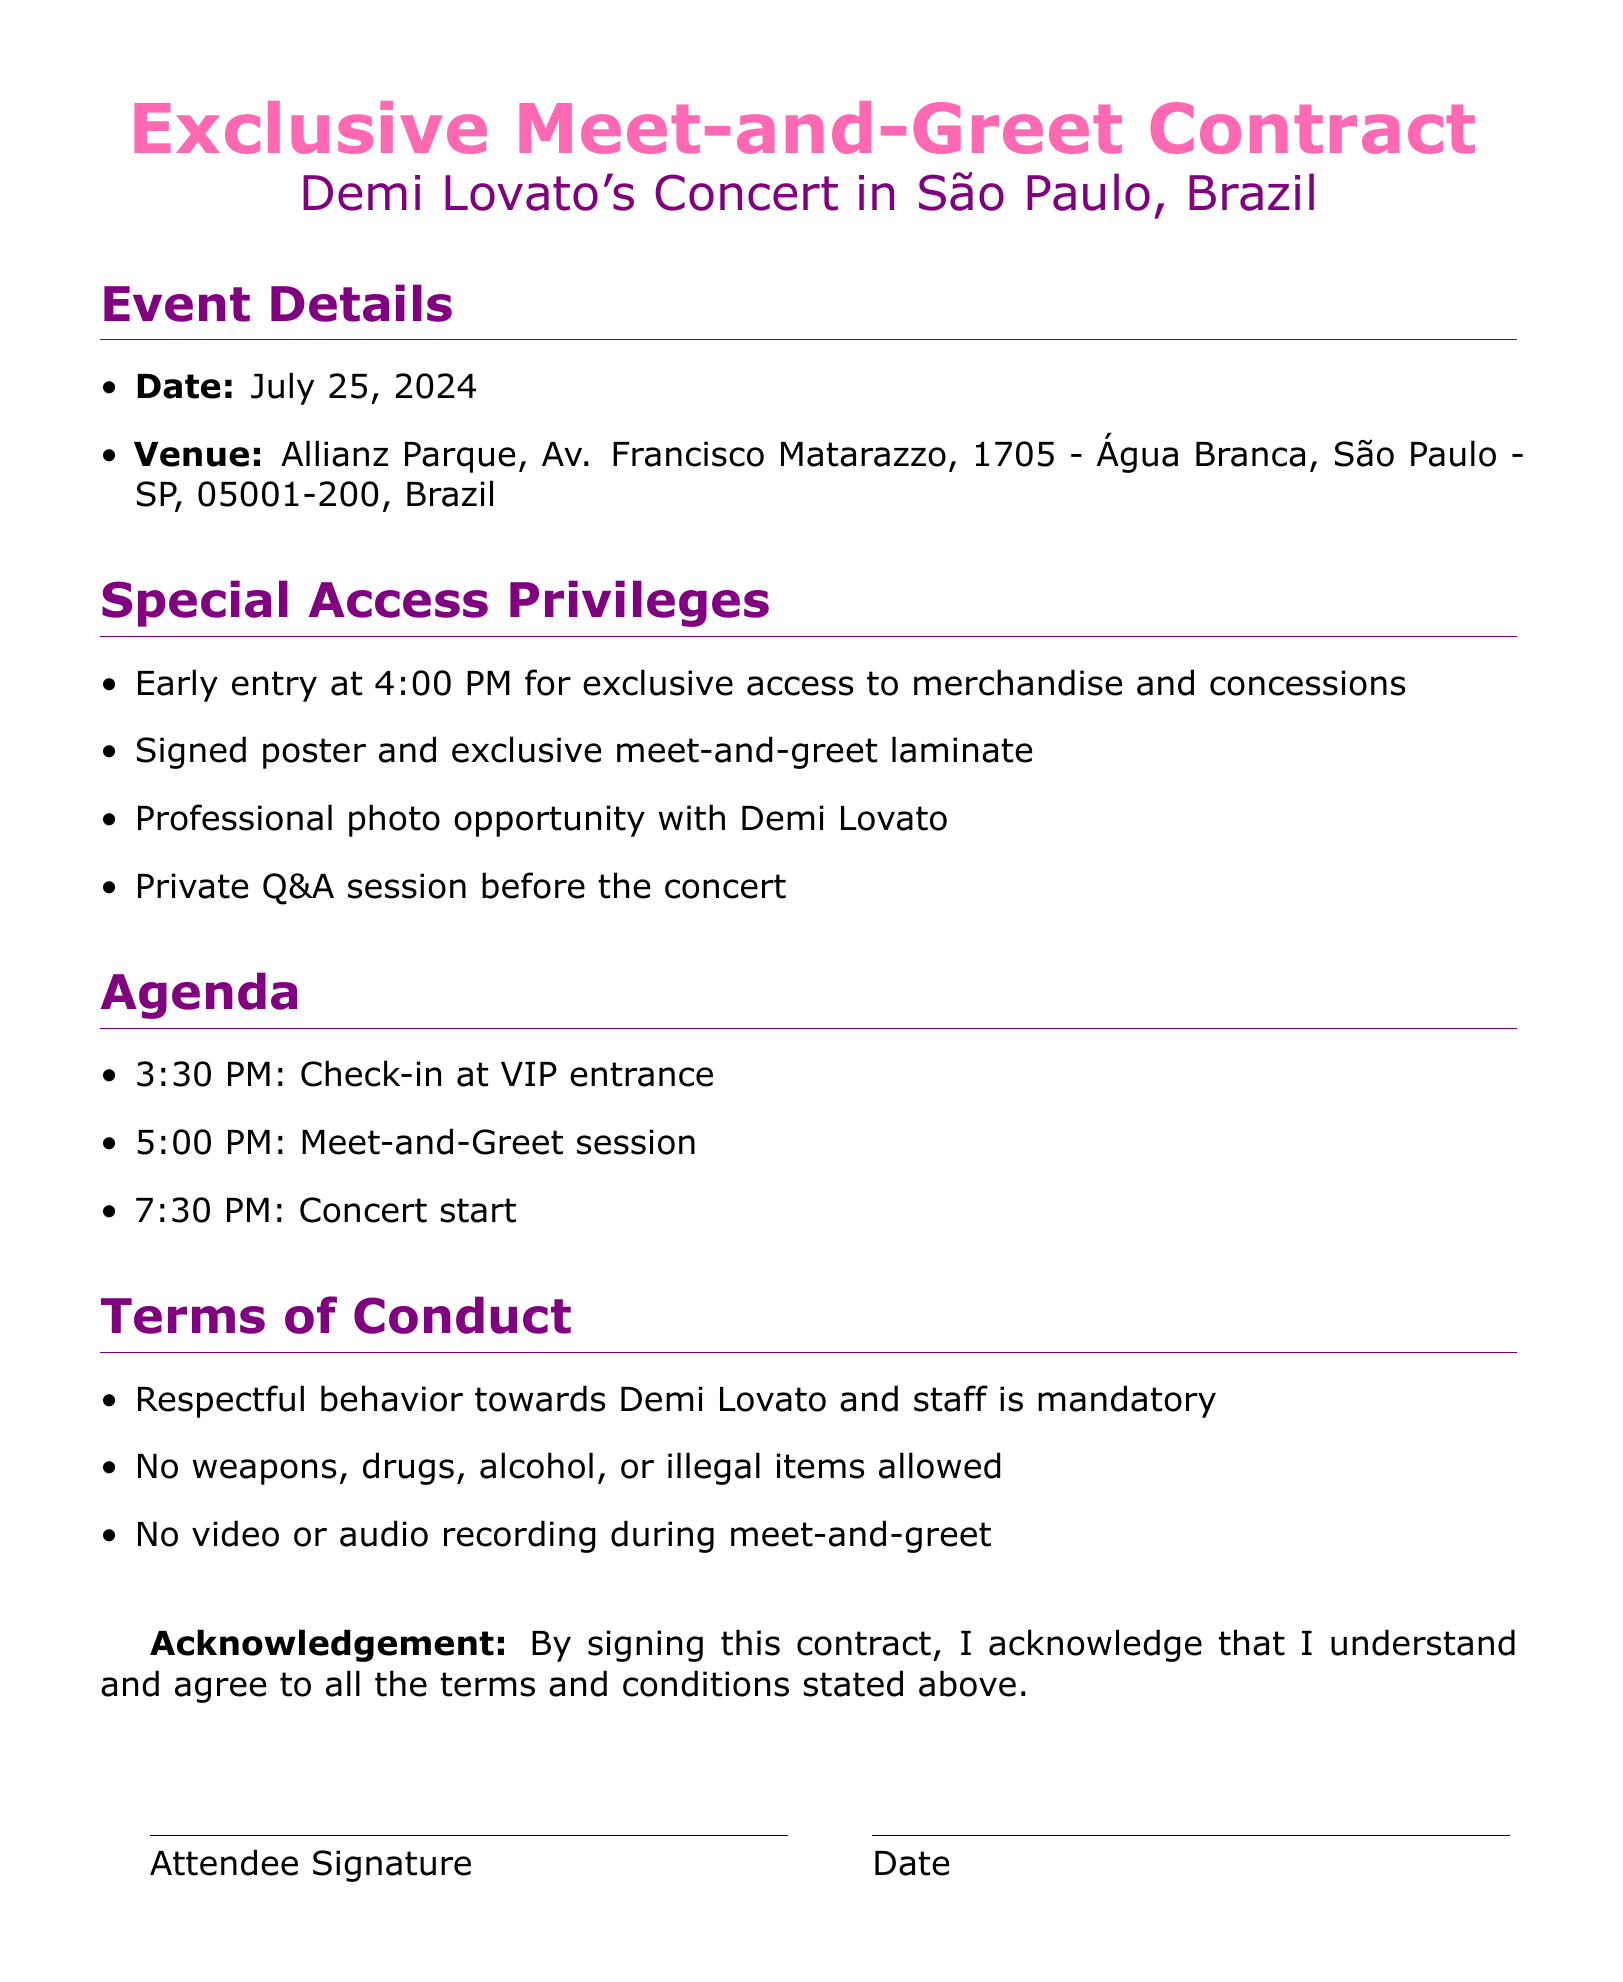What is the event date? The event date is explicitly mentioned in the document under Event Details.
Answer: July 25, 2024 What is the venue for the concert? The concert venue is listed under Event Details, providing the full name and address.
Answer: Allianz Parque, Av. Francisco Matarazzo, 1705 - Água Branca, São Paulo - SP, 05001-200, Brazil What time does check-in start? The check-in time is specified in the Agenda section of the document.
Answer: 3:30 PM What special access privilege is mentioned for early entry? The special access privilege is outlined in the Special Access Privileges section, highlighting early entry benefits.
Answer: Exclusive access to merchandise and concessions What is the first activity scheduled in the agenda? The first scheduled activity is provided under the Agenda section, listing the timings and events.
Answer: Check-in at VIP entrance What behavior is mandatory during the meet-and-greet? This is found under the Terms of Conduct section, which outlines required behavior.
Answer: Respectful behavior Are video recordings allowed during the meet-and-greet? This question relates to specific rules detailed in the Terms of Conduct section.
Answer: No What item will attendees receive that signifies the meet-and-greet? This is mentioned under the Special Access Privileges section.
Answer: Signed poster and exclusive meet-and-greet laminate 